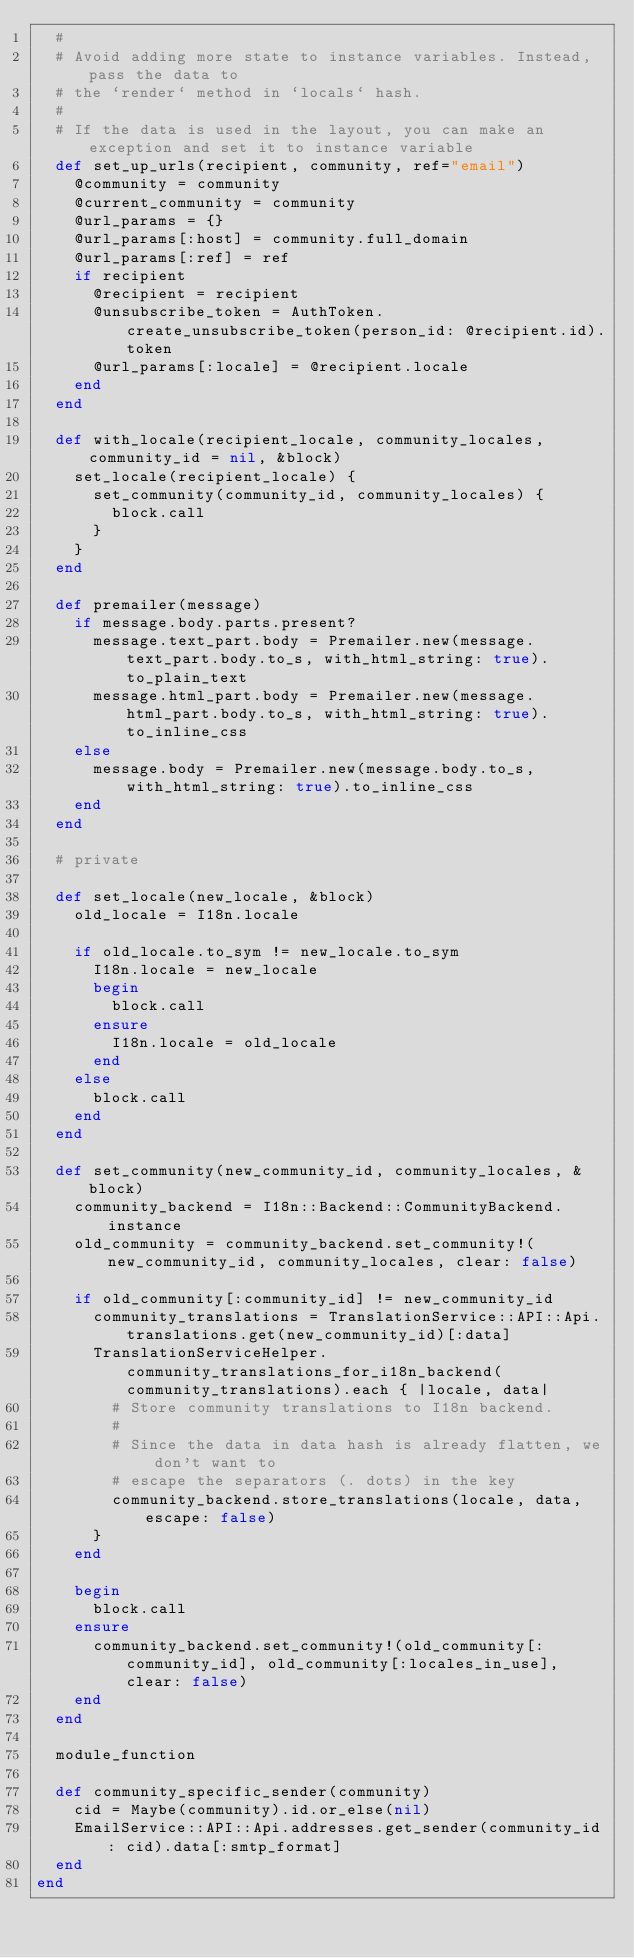Convert code to text. <code><loc_0><loc_0><loc_500><loc_500><_Ruby_>  #
  # Avoid adding more state to instance variables. Instead, pass the data to
  # the `render` method in `locals` hash.
  #
  # If the data is used in the layout, you can make an exception and set it to instance variable
  def set_up_urls(recipient, community, ref="email")
    @community = community
    @current_community = community
    @url_params = {}
    @url_params[:host] = community.full_domain
    @url_params[:ref] = ref
    if recipient
      @recipient = recipient
      @unsubscribe_token = AuthToken.create_unsubscribe_token(person_id: @recipient.id).token
      @url_params[:locale] = @recipient.locale
    end
  end

  def with_locale(recipient_locale, community_locales, community_id = nil, &block)
    set_locale(recipient_locale) {
      set_community(community_id, community_locales) {
        block.call
      }
    }
  end

  def premailer(message)
    if message.body.parts.present?
      message.text_part.body = Premailer.new(message.text_part.body.to_s, with_html_string: true).to_plain_text
      message.html_part.body = Premailer.new(message.html_part.body.to_s, with_html_string: true).to_inline_css
    else
      message.body = Premailer.new(message.body.to_s, with_html_string: true).to_inline_css
    end
  end

  # private

  def set_locale(new_locale, &block)
    old_locale = I18n.locale

    if old_locale.to_sym != new_locale.to_sym
      I18n.locale = new_locale
      begin
        block.call
      ensure
        I18n.locale = old_locale
      end
    else
      block.call
    end
  end

  def set_community(new_community_id, community_locales, &block)
    community_backend = I18n::Backend::CommunityBackend.instance
    old_community = community_backend.set_community!(new_community_id, community_locales, clear: false)

    if old_community[:community_id] != new_community_id
      community_translations = TranslationService::API::Api.translations.get(new_community_id)[:data]
      TranslationServiceHelper.community_translations_for_i18n_backend(community_translations).each { |locale, data|
        # Store community translations to I18n backend.
        #
        # Since the data in data hash is already flatten, we don't want to
        # escape the separators (. dots) in the key
        community_backend.store_translations(locale, data, escape: false)
      }
    end

    begin
      block.call
    ensure
      community_backend.set_community!(old_community[:community_id], old_community[:locales_in_use], clear: false)
    end
  end

  module_function

  def community_specific_sender(community)
    cid = Maybe(community).id.or_else(nil)
    EmailService::API::Api.addresses.get_sender(community_id: cid).data[:smtp_format]
  end
end
</code> 